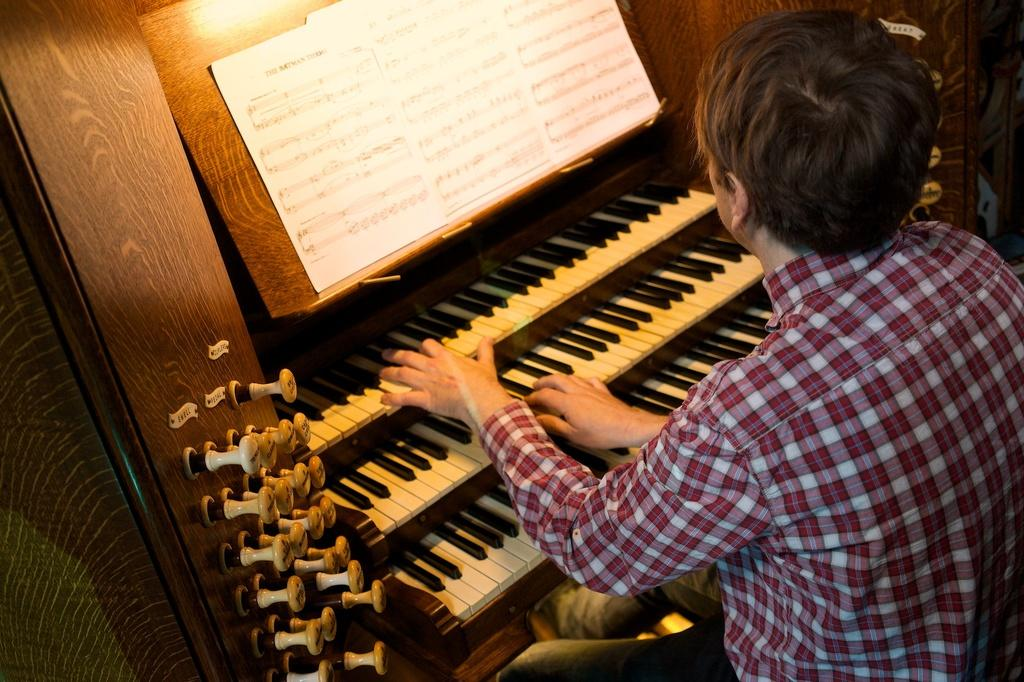What is the man in the image doing? The man is sitting on a chair and playing a piano keyboard. What can be found on the piano keyboard? There are papers with lyrics on the piano keyboard. What is the color pattern of the keys on the piano keyboard? The keys on the piano keyboard are in black and white color. What additional features are present on the piano keyboard? There are buttons on the piano keyboard. What type of pie is being served as a punishment in the image? There is no pie or punishment present in the image; it features a man playing a piano keyboard. What kind of marble is visible on the piano keyboard? There is no marble present on the piano keyboard in the image. 